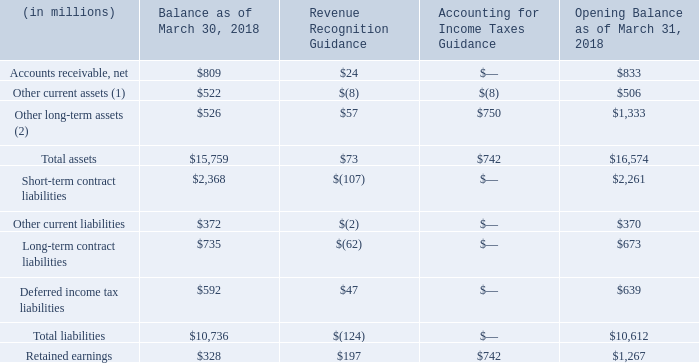Opening Balance Sheet Adjustments
The following summarizes the effect of adopting the above new accounting standards:
(1) The balance as of March 30, 2018, includes income tax receivable and prepaid income taxes of $107 million and short-term deferred commissions of $94 million. The opening balance as of March 31, 2018, includes income tax receivable and prepaid income taxes of $99 million and short-term deferred commissions of $86 million.
(2) The balance as of March 30, 2018, includes long-term deferred commissions of $35 million, long-term income tax receivable and prepaid income taxes of $61 million and deferred income tax assets of $46 million. The opening balance as of March 31, 2018, includes long-term deferred commissions of $92 million, long-term income tax receivable and prepaid income taxes of $29 million, and deferred income tax assets of $828 million.
What does the table show? Summarizes the effect of adopting the above new accounting standards. What is the Opening balance as of March 31, 2018 for Accounts receivable, net?
Answer scale should be: million. $809. What is the Opening balance as of March 31, 2018 for Total assets?
Answer scale should be: million. $16,574. What is the percentage increase in Accounts receivable, net from Balance as of March 30, 2018 to Opening balance as of March 31, 2018?
Answer scale should be: percent. 24/809
Answer: 2.97. What is the percentage increase in Total assets from Balance as of March 30, 2018 to Opening balance as of March 31, 2018?
Answer scale should be: percent. (73+742)/15,759
Answer: 5.17. What is the percentage change in Total liabilities from Balance as of March 30, 2018 to Opening balance as of March 31, 2018?
Answer scale should be: percent. -124/10,736
Answer: -1.15. 